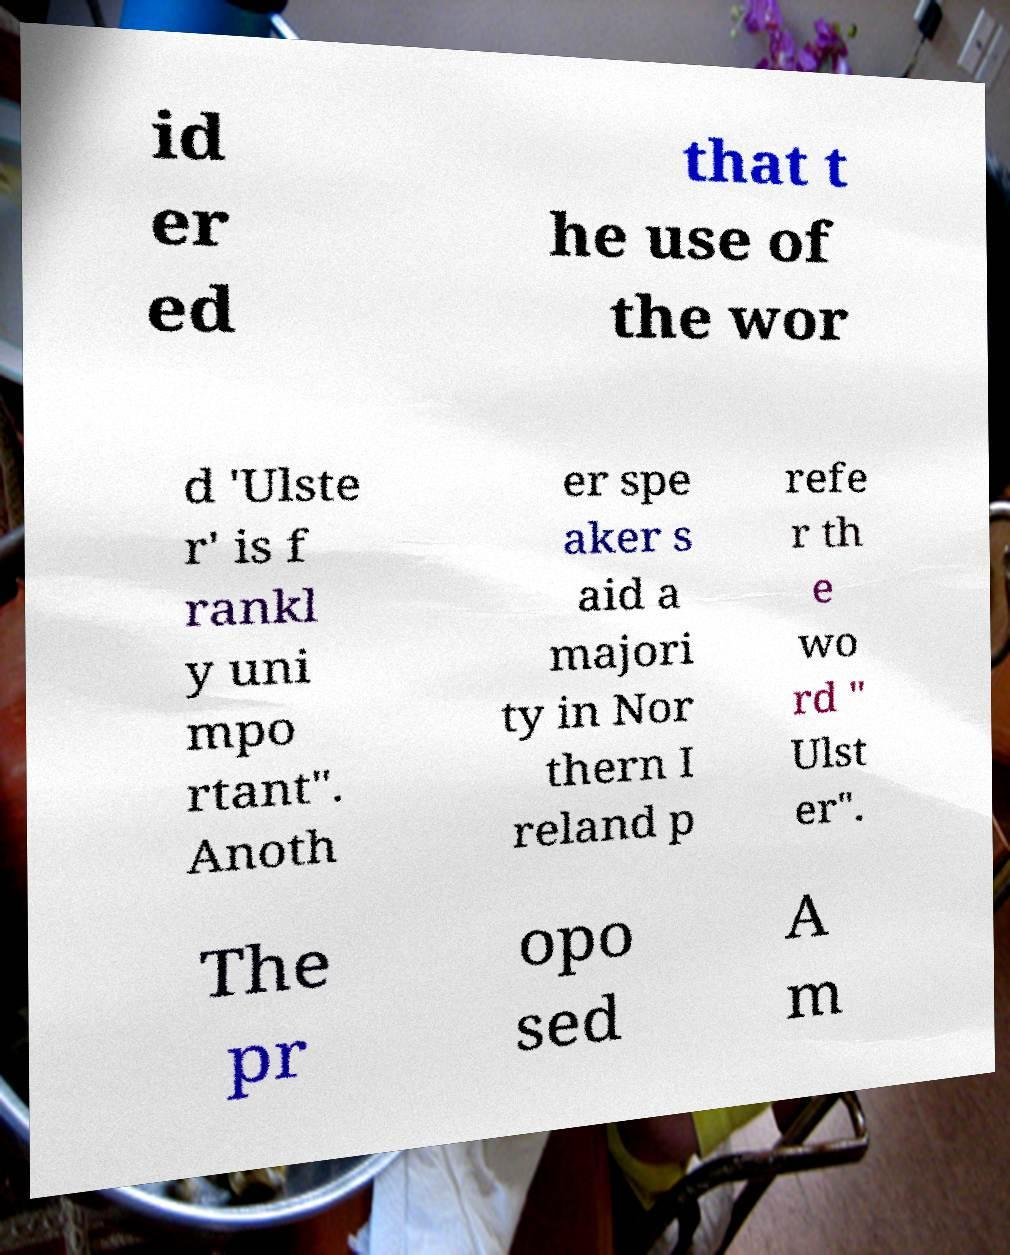Can you read and provide the text displayed in the image?This photo seems to have some interesting text. Can you extract and type it out for me? id er ed that t he use of the wor d 'Ulste r' is f rankl y uni mpo rtant". Anoth er spe aker s aid a majori ty in Nor thern I reland p refe r th e wo rd " Ulst er". The pr opo sed A m 